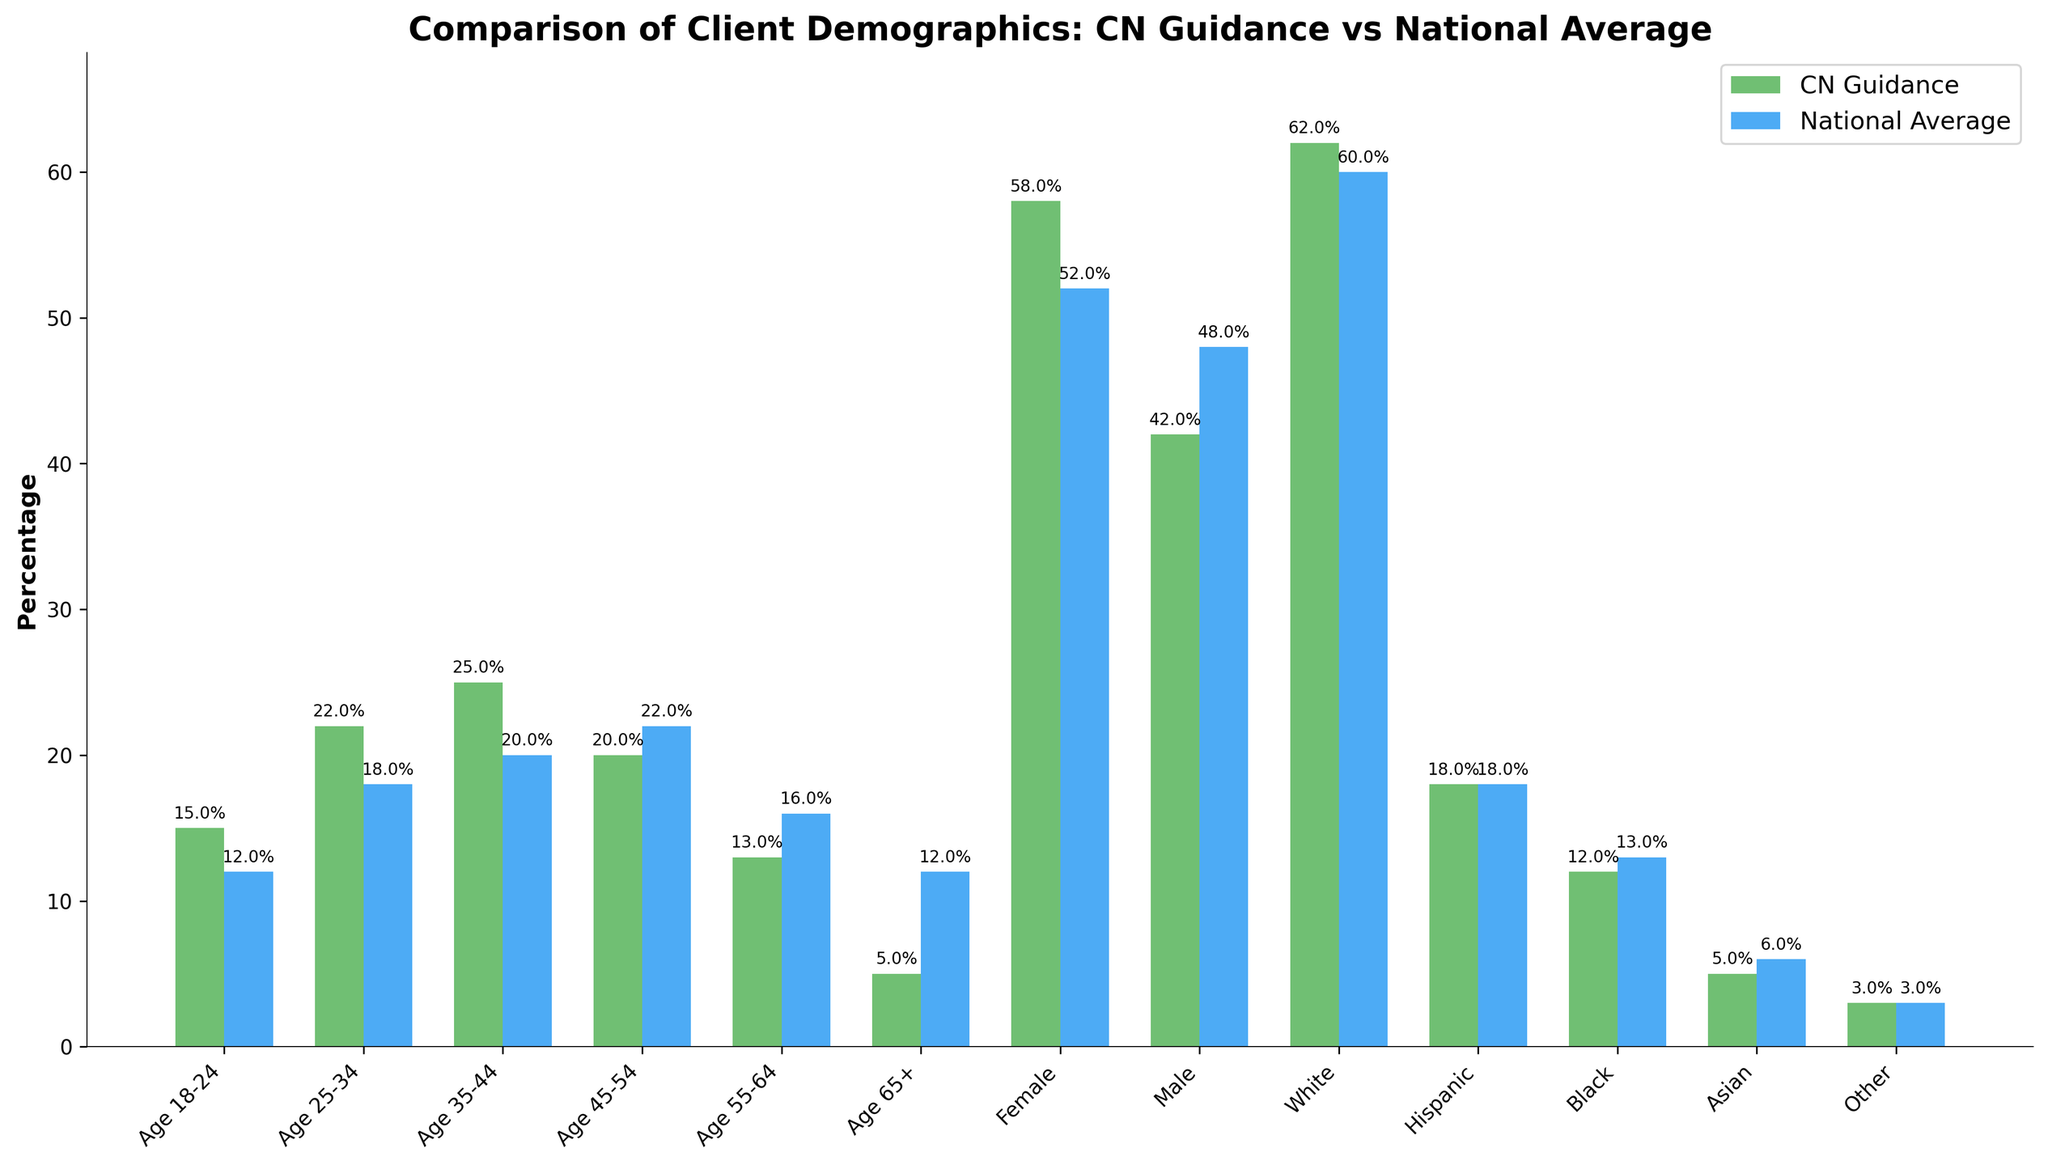What age group has the highest percentage of clients at CN Guidance & Counseling Services? The bars represent age groups for CN Guidance & Counseling Services. The bar with the highest percentage is for Age 35-44.
Answer: Age 35-44 Which gender has a higher percentage at CN Guidance & Counseling Services compared to the national average? Comparing the bars for Female and Male categories between CN Guidance & Counseling Services and the national average, Female has a higher percentage at CN Guidance (58%) compared to the national average (52%).
Answer: Female How does the percentage of clients aged 55-64 at CN Guidance & Counseling Services compare to the national average? The bar for Age 55-64 at CN Guidance shows 13%, and the bar for the national average shows 16%, indicating CN Guidance has a lower percentage for this age group.
Answer: CN Guidance has a lower percentage Which ethnic group has the largest difference in percentage between CN Guidance & Counseling Services and the national average? Subtracting the percentages for each ethnic group, the largest difference is found in Age 65+ with 7% difference (12% national average - 5% CN Guidance).
Answer: Age 65+ Are there any categories where CN Guidance & Counseling Services and the national average have the same percentage? The only category where both CN Guidance & Counseling Services and the national average have the same percentage is for the Hispanic ethnicity category, both showing 18%.
Answer: Hispanic What is the combined percentage of clients aged 18-34 at CN Guidance & Counseling Services? Adding the percentages for Age 18-24 and Age 25-34 at CN Guidance: 15% + 22% = 37%.
Answer: 37% Which gender has the lowest percentage at CN Guidance & Counseling Services? Checking the bars for Female and Male, the Male category has a lower percentage at CN Guidance (42%).
Answer: Male What visual difference can you observe between the 'White' ethnicity bar for CN Guidance & Counseling Services and the national average? The bar for the White ethnicity at CN Guidance is slightly taller (62%) than the corresponding bar for the national average (60%).
Answer: CN Guidance bar is taller Which age group has a lower percentage at CN Guidance & Counseling Services compared to the national average? The age groups to consider are Age 45-54, Age 55-64, and Age 65+. The Age 55-64 group shows CN Guidance at 13%, lower than the national average of 16%.
Answer: Age 55-64 What is the difference in percentage between the clients aged 35-44 and those aged 65+ at CN Guidance & Counseling Services? Taking the percentage for Age 35-44 (25%) and subtracting the percentage for Age 65+ (5%): 25% - 5% = 20%.
Answer: 20% 